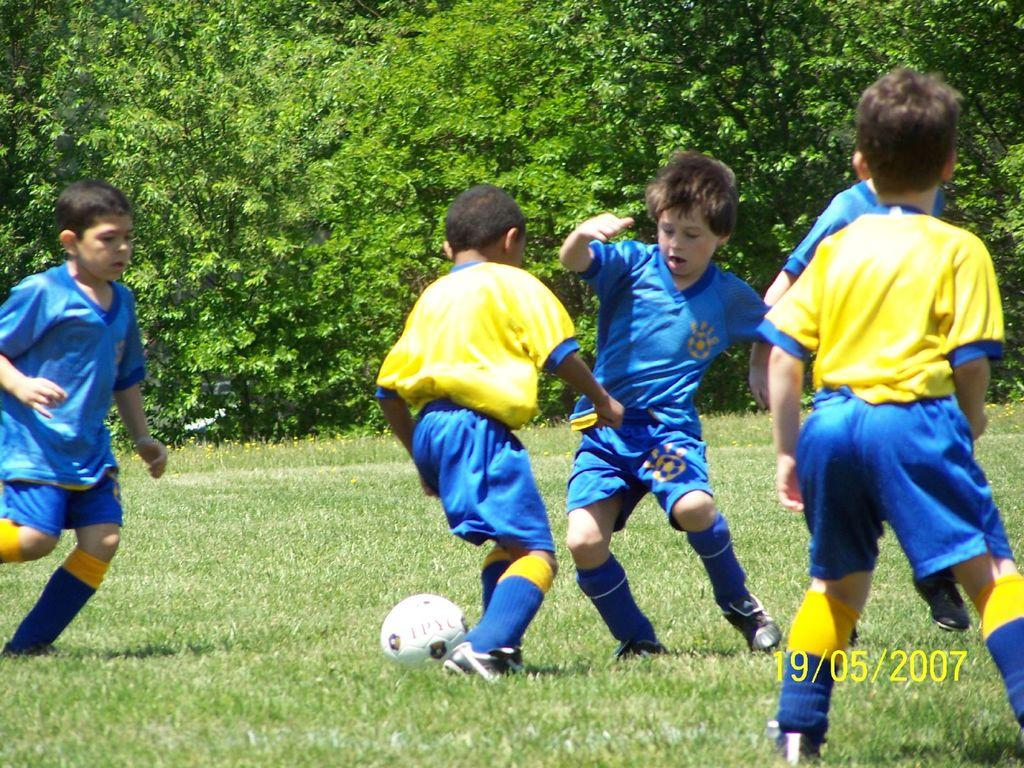What activity are the kids engaged in within the image? The kids are playing football in the image. Where is the football game taking place? The football game is taking place on a grassland. What can be seen in the background of the image? There are trees in the background of the image. Is there any additional information provided about the image? Yes, the image has a date displayed on the bottom right corner. What type of prose is being recited by the kids during the football game? There is no indication in the image that the kids are reciting any prose during the football game. 